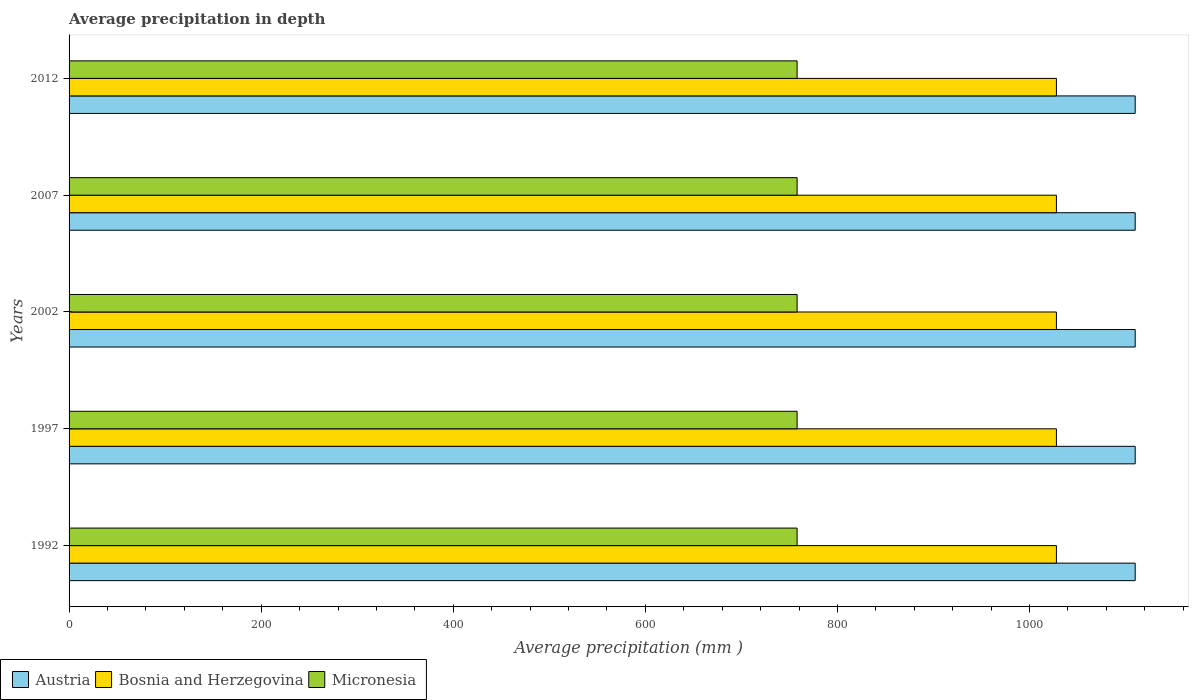How many groups of bars are there?
Your response must be concise. 5. How many bars are there on the 4th tick from the top?
Provide a short and direct response. 3. What is the label of the 1st group of bars from the top?
Your response must be concise. 2012. In how many cases, is the number of bars for a given year not equal to the number of legend labels?
Your answer should be compact. 0. What is the average precipitation in Bosnia and Herzegovina in 1997?
Make the answer very short. 1028. Across all years, what is the maximum average precipitation in Micronesia?
Your response must be concise. 758. Across all years, what is the minimum average precipitation in Austria?
Give a very brief answer. 1110. In which year was the average precipitation in Austria minimum?
Provide a short and direct response. 1992. What is the total average precipitation in Austria in the graph?
Ensure brevity in your answer.  5550. What is the difference between the average precipitation in Bosnia and Herzegovina in 2007 and the average precipitation in Micronesia in 1997?
Keep it short and to the point. 270. What is the average average precipitation in Micronesia per year?
Provide a short and direct response. 758. In the year 1997, what is the difference between the average precipitation in Micronesia and average precipitation in Austria?
Your answer should be very brief. -352. In how many years, is the average precipitation in Micronesia greater than 400 mm?
Offer a terse response. 5. Is the average precipitation in Austria in 1997 less than that in 2007?
Provide a short and direct response. No. What is the difference between the highest and the lowest average precipitation in Bosnia and Herzegovina?
Ensure brevity in your answer.  0. In how many years, is the average precipitation in Micronesia greater than the average average precipitation in Micronesia taken over all years?
Your response must be concise. 0. Is the sum of the average precipitation in Austria in 1992 and 1997 greater than the maximum average precipitation in Bosnia and Herzegovina across all years?
Ensure brevity in your answer.  Yes. What does the 3rd bar from the top in 2007 represents?
Make the answer very short. Austria. What does the 2nd bar from the bottom in 1992 represents?
Offer a very short reply. Bosnia and Herzegovina. What is the difference between two consecutive major ticks on the X-axis?
Offer a very short reply. 200. Are the values on the major ticks of X-axis written in scientific E-notation?
Your answer should be compact. No. Does the graph contain any zero values?
Ensure brevity in your answer.  No. Does the graph contain grids?
Offer a very short reply. No. Where does the legend appear in the graph?
Your response must be concise. Bottom left. How many legend labels are there?
Provide a short and direct response. 3. What is the title of the graph?
Offer a terse response. Average precipitation in depth. Does "Panama" appear as one of the legend labels in the graph?
Make the answer very short. No. What is the label or title of the X-axis?
Your response must be concise. Average precipitation (mm ). What is the label or title of the Y-axis?
Offer a very short reply. Years. What is the Average precipitation (mm ) in Austria in 1992?
Your answer should be compact. 1110. What is the Average precipitation (mm ) of Bosnia and Herzegovina in 1992?
Your answer should be compact. 1028. What is the Average precipitation (mm ) of Micronesia in 1992?
Make the answer very short. 758. What is the Average precipitation (mm ) in Austria in 1997?
Give a very brief answer. 1110. What is the Average precipitation (mm ) in Bosnia and Herzegovina in 1997?
Your answer should be compact. 1028. What is the Average precipitation (mm ) in Micronesia in 1997?
Keep it short and to the point. 758. What is the Average precipitation (mm ) in Austria in 2002?
Offer a terse response. 1110. What is the Average precipitation (mm ) in Bosnia and Herzegovina in 2002?
Offer a very short reply. 1028. What is the Average precipitation (mm ) of Micronesia in 2002?
Your response must be concise. 758. What is the Average precipitation (mm ) in Austria in 2007?
Give a very brief answer. 1110. What is the Average precipitation (mm ) of Bosnia and Herzegovina in 2007?
Offer a very short reply. 1028. What is the Average precipitation (mm ) in Micronesia in 2007?
Keep it short and to the point. 758. What is the Average precipitation (mm ) in Austria in 2012?
Offer a terse response. 1110. What is the Average precipitation (mm ) of Bosnia and Herzegovina in 2012?
Your answer should be compact. 1028. What is the Average precipitation (mm ) in Micronesia in 2012?
Your response must be concise. 758. Across all years, what is the maximum Average precipitation (mm ) in Austria?
Your response must be concise. 1110. Across all years, what is the maximum Average precipitation (mm ) of Bosnia and Herzegovina?
Offer a very short reply. 1028. Across all years, what is the maximum Average precipitation (mm ) of Micronesia?
Provide a short and direct response. 758. Across all years, what is the minimum Average precipitation (mm ) of Austria?
Your response must be concise. 1110. Across all years, what is the minimum Average precipitation (mm ) in Bosnia and Herzegovina?
Your response must be concise. 1028. Across all years, what is the minimum Average precipitation (mm ) of Micronesia?
Your answer should be compact. 758. What is the total Average precipitation (mm ) in Austria in the graph?
Your answer should be very brief. 5550. What is the total Average precipitation (mm ) in Bosnia and Herzegovina in the graph?
Your response must be concise. 5140. What is the total Average precipitation (mm ) in Micronesia in the graph?
Give a very brief answer. 3790. What is the difference between the Average precipitation (mm ) in Austria in 1992 and that in 1997?
Offer a terse response. 0. What is the difference between the Average precipitation (mm ) in Bosnia and Herzegovina in 1992 and that in 1997?
Ensure brevity in your answer.  0. What is the difference between the Average precipitation (mm ) in Micronesia in 1992 and that in 2002?
Your response must be concise. 0. What is the difference between the Average precipitation (mm ) in Austria in 1992 and that in 2007?
Offer a terse response. 0. What is the difference between the Average precipitation (mm ) of Bosnia and Herzegovina in 1992 and that in 2012?
Your response must be concise. 0. What is the difference between the Average precipitation (mm ) of Austria in 1997 and that in 2002?
Your answer should be very brief. 0. What is the difference between the Average precipitation (mm ) in Bosnia and Herzegovina in 1997 and that in 2002?
Make the answer very short. 0. What is the difference between the Average precipitation (mm ) in Micronesia in 1997 and that in 2007?
Offer a very short reply. 0. What is the difference between the Average precipitation (mm ) in Bosnia and Herzegovina in 1997 and that in 2012?
Your answer should be compact. 0. What is the difference between the Average precipitation (mm ) of Micronesia in 1997 and that in 2012?
Offer a very short reply. 0. What is the difference between the Average precipitation (mm ) in Austria in 2002 and that in 2007?
Provide a succinct answer. 0. What is the difference between the Average precipitation (mm ) of Bosnia and Herzegovina in 2002 and that in 2007?
Provide a succinct answer. 0. What is the difference between the Average precipitation (mm ) in Micronesia in 2002 and that in 2007?
Provide a succinct answer. 0. What is the difference between the Average precipitation (mm ) in Austria in 2002 and that in 2012?
Your answer should be compact. 0. What is the difference between the Average precipitation (mm ) of Micronesia in 2002 and that in 2012?
Your answer should be very brief. 0. What is the difference between the Average precipitation (mm ) in Austria in 2007 and that in 2012?
Your response must be concise. 0. What is the difference between the Average precipitation (mm ) of Micronesia in 2007 and that in 2012?
Make the answer very short. 0. What is the difference between the Average precipitation (mm ) in Austria in 1992 and the Average precipitation (mm ) in Micronesia in 1997?
Give a very brief answer. 352. What is the difference between the Average precipitation (mm ) of Bosnia and Herzegovina in 1992 and the Average precipitation (mm ) of Micronesia in 1997?
Your answer should be compact. 270. What is the difference between the Average precipitation (mm ) in Austria in 1992 and the Average precipitation (mm ) in Micronesia in 2002?
Ensure brevity in your answer.  352. What is the difference between the Average precipitation (mm ) in Bosnia and Herzegovina in 1992 and the Average precipitation (mm ) in Micronesia in 2002?
Give a very brief answer. 270. What is the difference between the Average precipitation (mm ) in Austria in 1992 and the Average precipitation (mm ) in Micronesia in 2007?
Your answer should be very brief. 352. What is the difference between the Average precipitation (mm ) of Bosnia and Herzegovina in 1992 and the Average precipitation (mm ) of Micronesia in 2007?
Your answer should be very brief. 270. What is the difference between the Average precipitation (mm ) of Austria in 1992 and the Average precipitation (mm ) of Bosnia and Herzegovina in 2012?
Keep it short and to the point. 82. What is the difference between the Average precipitation (mm ) of Austria in 1992 and the Average precipitation (mm ) of Micronesia in 2012?
Ensure brevity in your answer.  352. What is the difference between the Average precipitation (mm ) of Bosnia and Herzegovina in 1992 and the Average precipitation (mm ) of Micronesia in 2012?
Make the answer very short. 270. What is the difference between the Average precipitation (mm ) in Austria in 1997 and the Average precipitation (mm ) in Micronesia in 2002?
Make the answer very short. 352. What is the difference between the Average precipitation (mm ) in Bosnia and Herzegovina in 1997 and the Average precipitation (mm ) in Micronesia in 2002?
Make the answer very short. 270. What is the difference between the Average precipitation (mm ) of Austria in 1997 and the Average precipitation (mm ) of Micronesia in 2007?
Provide a succinct answer. 352. What is the difference between the Average precipitation (mm ) in Bosnia and Herzegovina in 1997 and the Average precipitation (mm ) in Micronesia in 2007?
Give a very brief answer. 270. What is the difference between the Average precipitation (mm ) in Austria in 1997 and the Average precipitation (mm ) in Micronesia in 2012?
Your answer should be very brief. 352. What is the difference between the Average precipitation (mm ) in Bosnia and Herzegovina in 1997 and the Average precipitation (mm ) in Micronesia in 2012?
Provide a succinct answer. 270. What is the difference between the Average precipitation (mm ) in Austria in 2002 and the Average precipitation (mm ) in Micronesia in 2007?
Your answer should be compact. 352. What is the difference between the Average precipitation (mm ) of Bosnia and Herzegovina in 2002 and the Average precipitation (mm ) of Micronesia in 2007?
Offer a very short reply. 270. What is the difference between the Average precipitation (mm ) in Austria in 2002 and the Average precipitation (mm ) in Bosnia and Herzegovina in 2012?
Your answer should be compact. 82. What is the difference between the Average precipitation (mm ) of Austria in 2002 and the Average precipitation (mm ) of Micronesia in 2012?
Provide a short and direct response. 352. What is the difference between the Average precipitation (mm ) of Bosnia and Herzegovina in 2002 and the Average precipitation (mm ) of Micronesia in 2012?
Provide a short and direct response. 270. What is the difference between the Average precipitation (mm ) in Austria in 2007 and the Average precipitation (mm ) in Bosnia and Herzegovina in 2012?
Your answer should be compact. 82. What is the difference between the Average precipitation (mm ) of Austria in 2007 and the Average precipitation (mm ) of Micronesia in 2012?
Offer a very short reply. 352. What is the difference between the Average precipitation (mm ) in Bosnia and Herzegovina in 2007 and the Average precipitation (mm ) in Micronesia in 2012?
Make the answer very short. 270. What is the average Average precipitation (mm ) of Austria per year?
Make the answer very short. 1110. What is the average Average precipitation (mm ) of Bosnia and Herzegovina per year?
Ensure brevity in your answer.  1028. What is the average Average precipitation (mm ) in Micronesia per year?
Give a very brief answer. 758. In the year 1992, what is the difference between the Average precipitation (mm ) in Austria and Average precipitation (mm ) in Micronesia?
Your response must be concise. 352. In the year 1992, what is the difference between the Average precipitation (mm ) of Bosnia and Herzegovina and Average precipitation (mm ) of Micronesia?
Offer a very short reply. 270. In the year 1997, what is the difference between the Average precipitation (mm ) in Austria and Average precipitation (mm ) in Micronesia?
Make the answer very short. 352. In the year 1997, what is the difference between the Average precipitation (mm ) of Bosnia and Herzegovina and Average precipitation (mm ) of Micronesia?
Your answer should be compact. 270. In the year 2002, what is the difference between the Average precipitation (mm ) in Austria and Average precipitation (mm ) in Bosnia and Herzegovina?
Make the answer very short. 82. In the year 2002, what is the difference between the Average precipitation (mm ) of Austria and Average precipitation (mm ) of Micronesia?
Offer a very short reply. 352. In the year 2002, what is the difference between the Average precipitation (mm ) of Bosnia and Herzegovina and Average precipitation (mm ) of Micronesia?
Your answer should be very brief. 270. In the year 2007, what is the difference between the Average precipitation (mm ) in Austria and Average precipitation (mm ) in Micronesia?
Your answer should be compact. 352. In the year 2007, what is the difference between the Average precipitation (mm ) in Bosnia and Herzegovina and Average precipitation (mm ) in Micronesia?
Ensure brevity in your answer.  270. In the year 2012, what is the difference between the Average precipitation (mm ) of Austria and Average precipitation (mm ) of Micronesia?
Your answer should be compact. 352. In the year 2012, what is the difference between the Average precipitation (mm ) of Bosnia and Herzegovina and Average precipitation (mm ) of Micronesia?
Keep it short and to the point. 270. What is the ratio of the Average precipitation (mm ) in Austria in 1992 to that in 1997?
Your answer should be compact. 1. What is the ratio of the Average precipitation (mm ) of Bosnia and Herzegovina in 1992 to that in 1997?
Give a very brief answer. 1. What is the ratio of the Average precipitation (mm ) of Austria in 1992 to that in 2002?
Your answer should be very brief. 1. What is the ratio of the Average precipitation (mm ) in Bosnia and Herzegovina in 1992 to that in 2002?
Provide a succinct answer. 1. What is the ratio of the Average precipitation (mm ) of Micronesia in 1992 to that in 2007?
Provide a short and direct response. 1. What is the ratio of the Average precipitation (mm ) in Austria in 1992 to that in 2012?
Ensure brevity in your answer.  1. What is the ratio of the Average precipitation (mm ) of Bosnia and Herzegovina in 1992 to that in 2012?
Offer a very short reply. 1. What is the ratio of the Average precipitation (mm ) of Micronesia in 1992 to that in 2012?
Your answer should be very brief. 1. What is the ratio of the Average precipitation (mm ) in Austria in 1997 to that in 2002?
Provide a short and direct response. 1. What is the ratio of the Average precipitation (mm ) of Bosnia and Herzegovina in 1997 to that in 2002?
Provide a succinct answer. 1. What is the ratio of the Average precipitation (mm ) of Micronesia in 1997 to that in 2002?
Ensure brevity in your answer.  1. What is the ratio of the Average precipitation (mm ) of Austria in 1997 to that in 2007?
Provide a succinct answer. 1. What is the ratio of the Average precipitation (mm ) of Micronesia in 1997 to that in 2007?
Offer a very short reply. 1. What is the ratio of the Average precipitation (mm ) of Micronesia in 1997 to that in 2012?
Your answer should be compact. 1. What is the ratio of the Average precipitation (mm ) of Micronesia in 2002 to that in 2007?
Keep it short and to the point. 1. What is the ratio of the Average precipitation (mm ) in Bosnia and Herzegovina in 2002 to that in 2012?
Ensure brevity in your answer.  1. What is the difference between the highest and the second highest Average precipitation (mm ) in Austria?
Offer a very short reply. 0. What is the difference between the highest and the second highest Average precipitation (mm ) of Bosnia and Herzegovina?
Offer a terse response. 0. What is the difference between the highest and the second highest Average precipitation (mm ) in Micronesia?
Give a very brief answer. 0. 